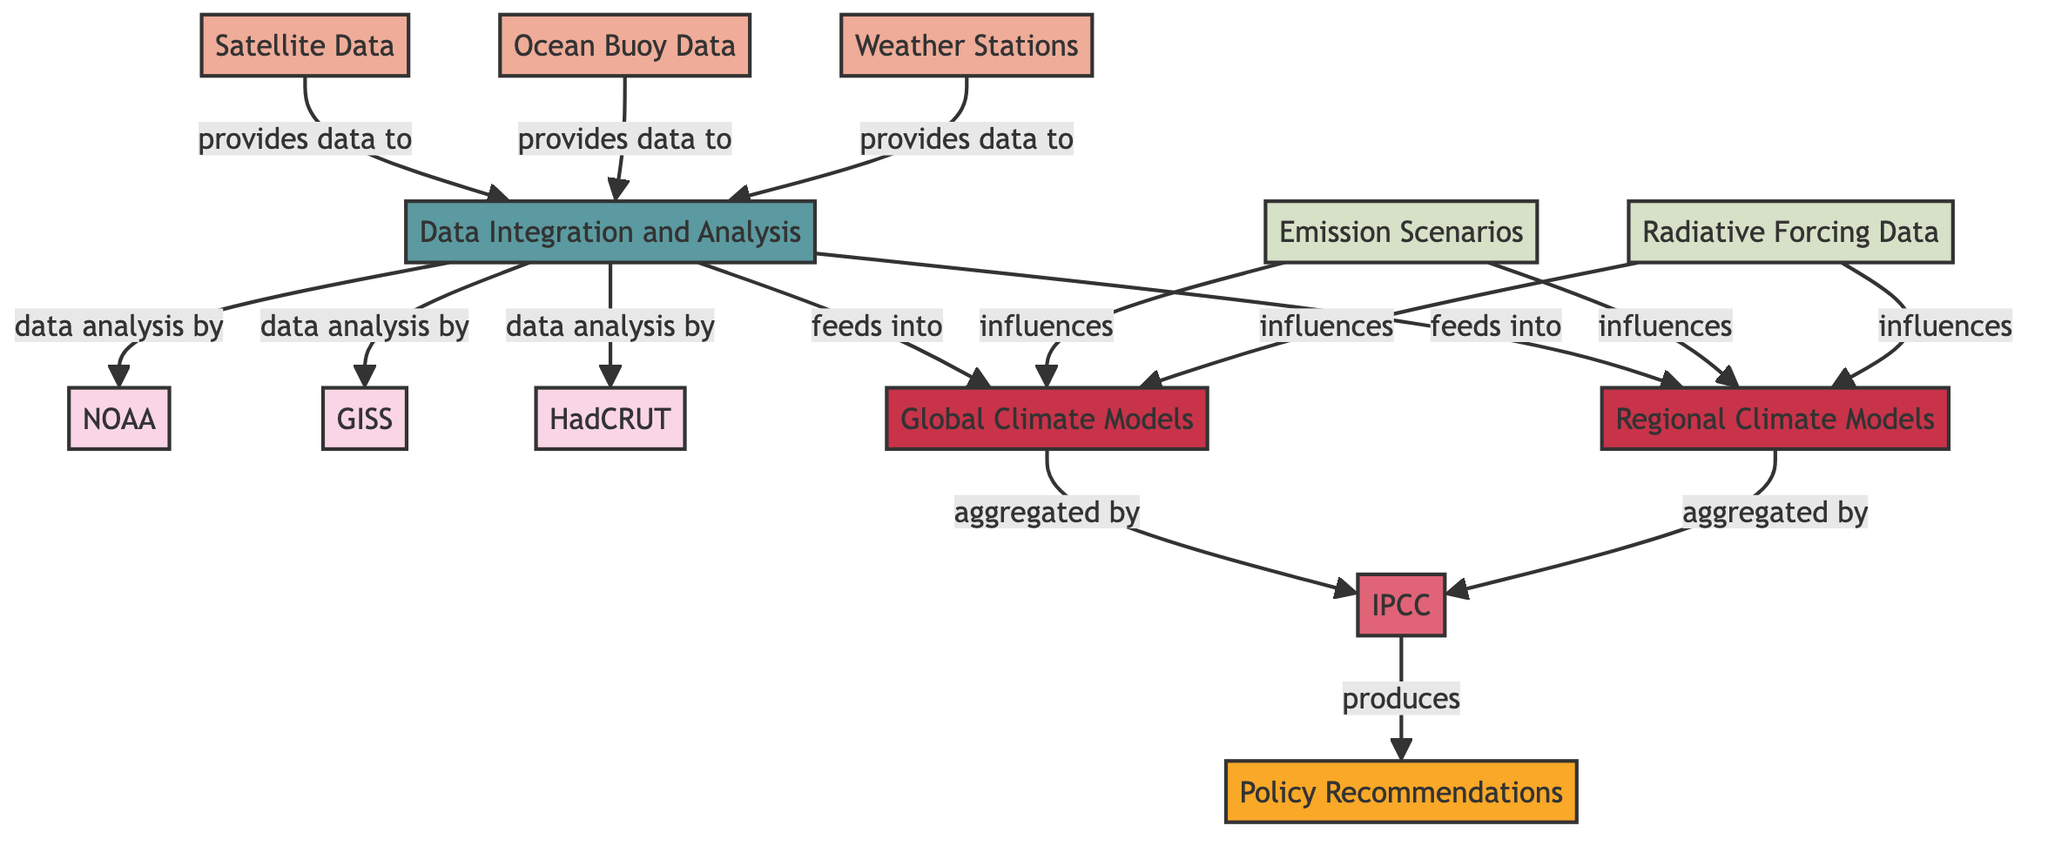What are the data sources provided to the Data Integration and Analysis process? The diagram lists three data sources: Satellite Data, Ocean Buoy Data, and Weather Stations. Each of these sources is connected by an edge labeled "provides data to," indicating their contribution to the Data Integration and Analysis process.
Answer: Satellite Data, Ocean Buoy Data, Weather Stations How many research institutions are involved in data analysis? The diagram includes three research institutions: NOAA, GISS, and HadCRUT. Each institution is directly connected to the Data Integration and Analysis process, which indicates their participation in the analysis of the collected data.
Answer: 3 What does the Global Climate Models node receive data from? The Global Climate Models node receives data from the Data Integration and Analysis process, which is denoted by the edge labeled "feeds into." This indicates that the output of the Data Integration and Analysis feeds into the Global Climate Models for further analysis.
Answer: Data Integration and Analysis What is the output produced by the IPCC? According to the diagram, the output produced by the IPCC is Policy Recommendations. This relationship is shown with an edge that connects the IPCC node to the Policy Recommendations node, indicating that the aggregation process leads to this final output.
Answer: Policy Recommendations Which input variable influences both Global Climate Models and Regional Climate Models? The diagram shows that Emission Scenarios influence both the Global Climate Models and Regional Climate Models. There are two edges from the Emission Scenarios node, each labeled "influences," leading to both model nodes.
Answer: Emission Scenarios Which data source does NOT feed into the Data Integration and Analysis process? The diagram presents three data sources that provide data to the Data Integration and Analysis process: Satellite Data, Ocean Buoy Data, and Weather Stations. Since there is no mention of any other data source, it can be concluded that any data source outside of these three does not connect to the process. Analyzing the nodes and edges shows no connections from other data sources.
Answer: None What step follows after the aggregation by the IPCC? Following the aggregation process by the IPCC, the next step is the production of Policy Recommendations. This is indicated by the edge labeled “produces” that directly links the IPCC to the Policy Recommendations node, highlighting the output of the aggregation process.
Answer: Policy Recommendations How many types of models are presented in the diagram? The diagram presents two types of models: Global Climate Models and Regional Climate Models. Each model type is represented as a distinct node in the diagram, showing that both models are part of the data flow process.
Answer: 2 Which input variable is associated with Radiative Forcing Data? The diagram shows that Radiative Forcing Data itself is an input variable that influences both Global Climate Models and Regional Climate Models. The edges leading towards both model types indicate its role in the data flow and modeling processes.
Answer: Radiative Forcing Data 